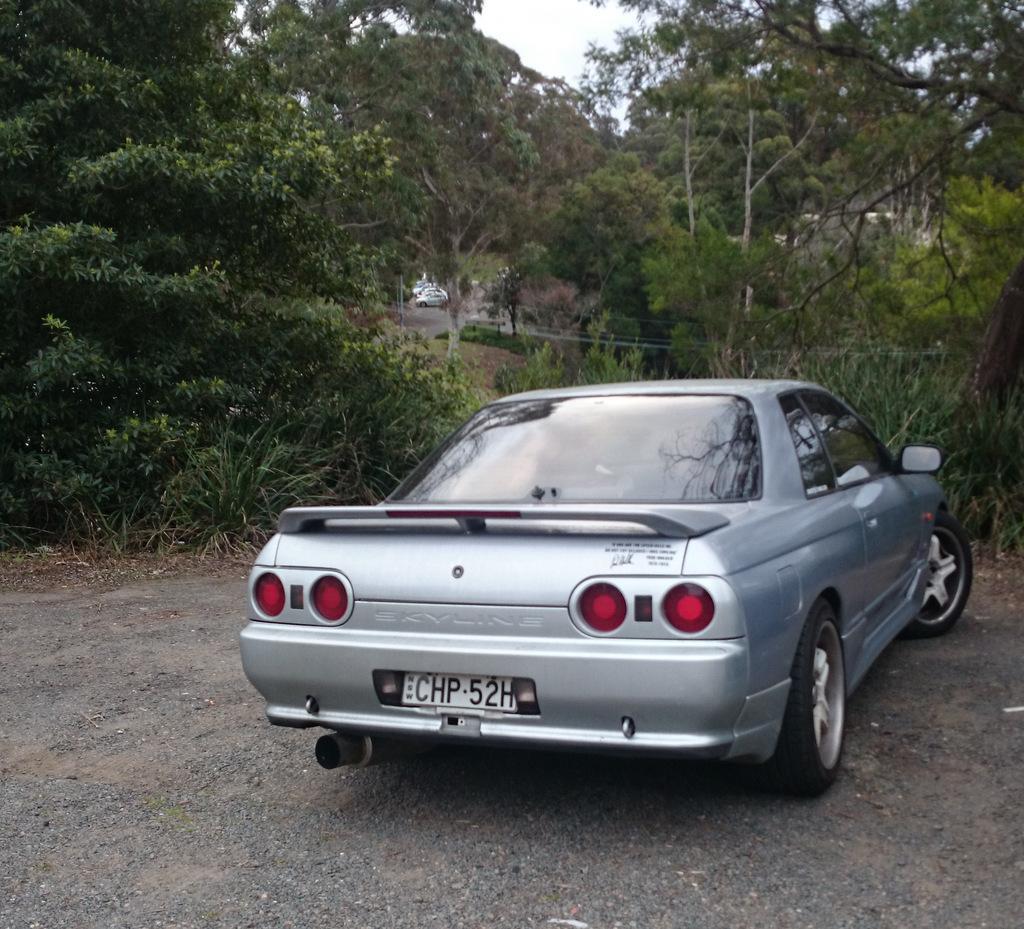Describe this image in one or two sentences. This picture is clicked outside. In the foreground we can see a car seems to be parked on the ground. In the center we can see the plants, trees. In the background we can see the sky and the vehicles. 